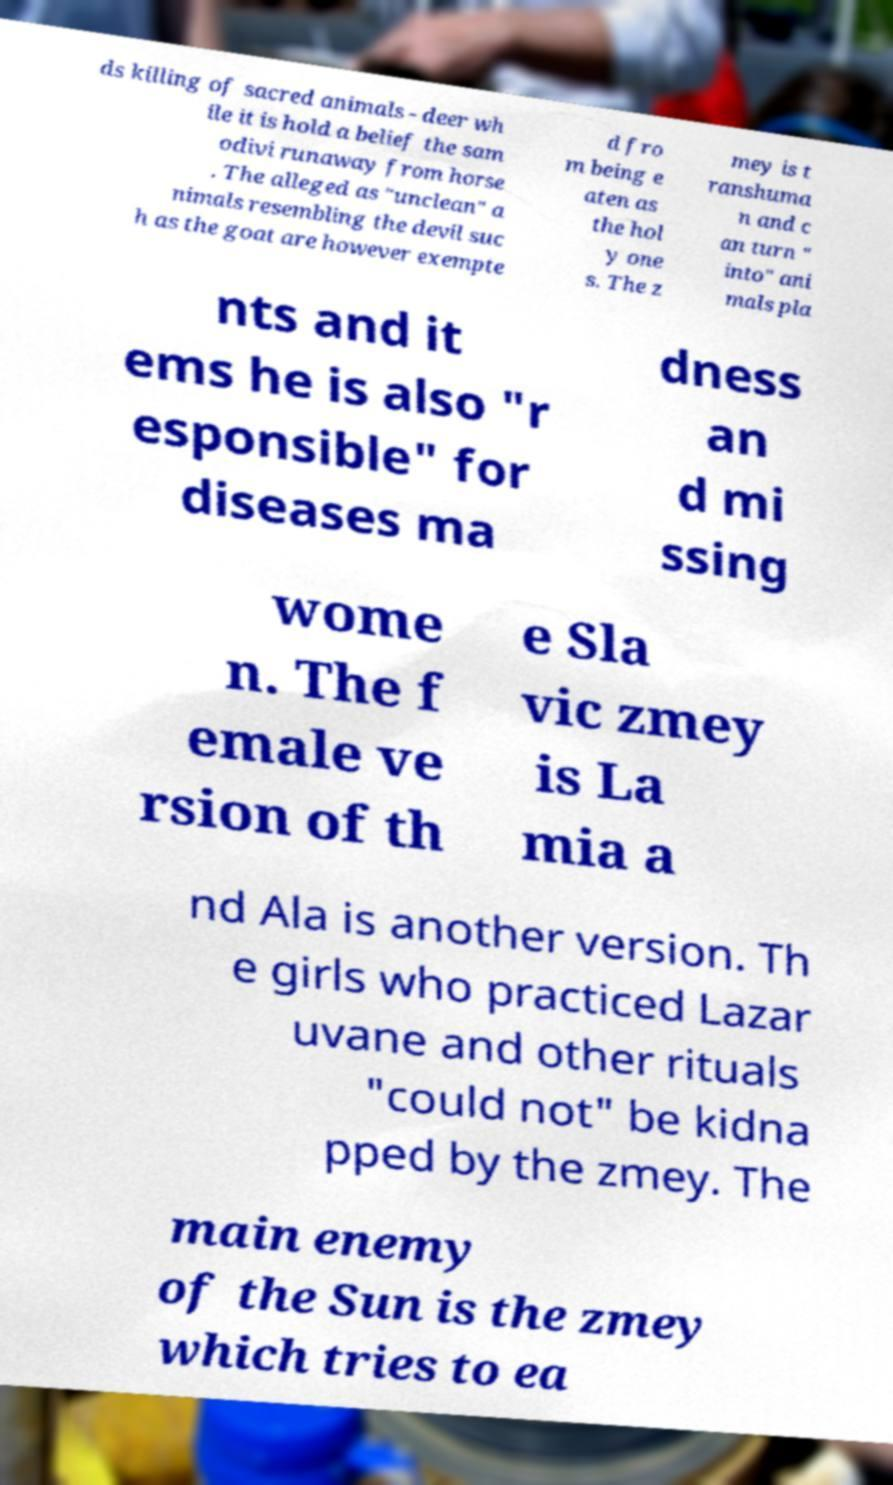Please identify and transcribe the text found in this image. ds killing of sacred animals - deer wh ile it is hold a belief the sam odivi runaway from horse . The alleged as "unclean" a nimals resembling the devil suc h as the goat are however exempte d fro m being e aten as the hol y one s. The z mey is t ranshuma n and c an turn " into" ani mals pla nts and it ems he is also "r esponsible" for diseases ma dness an d mi ssing wome n. The f emale ve rsion of th e Sla vic zmey is La mia a nd Ala is another version. Th e girls who practiced Lazar uvane and other rituals "could not" be kidna pped by the zmey. The main enemy of the Sun is the zmey which tries to ea 